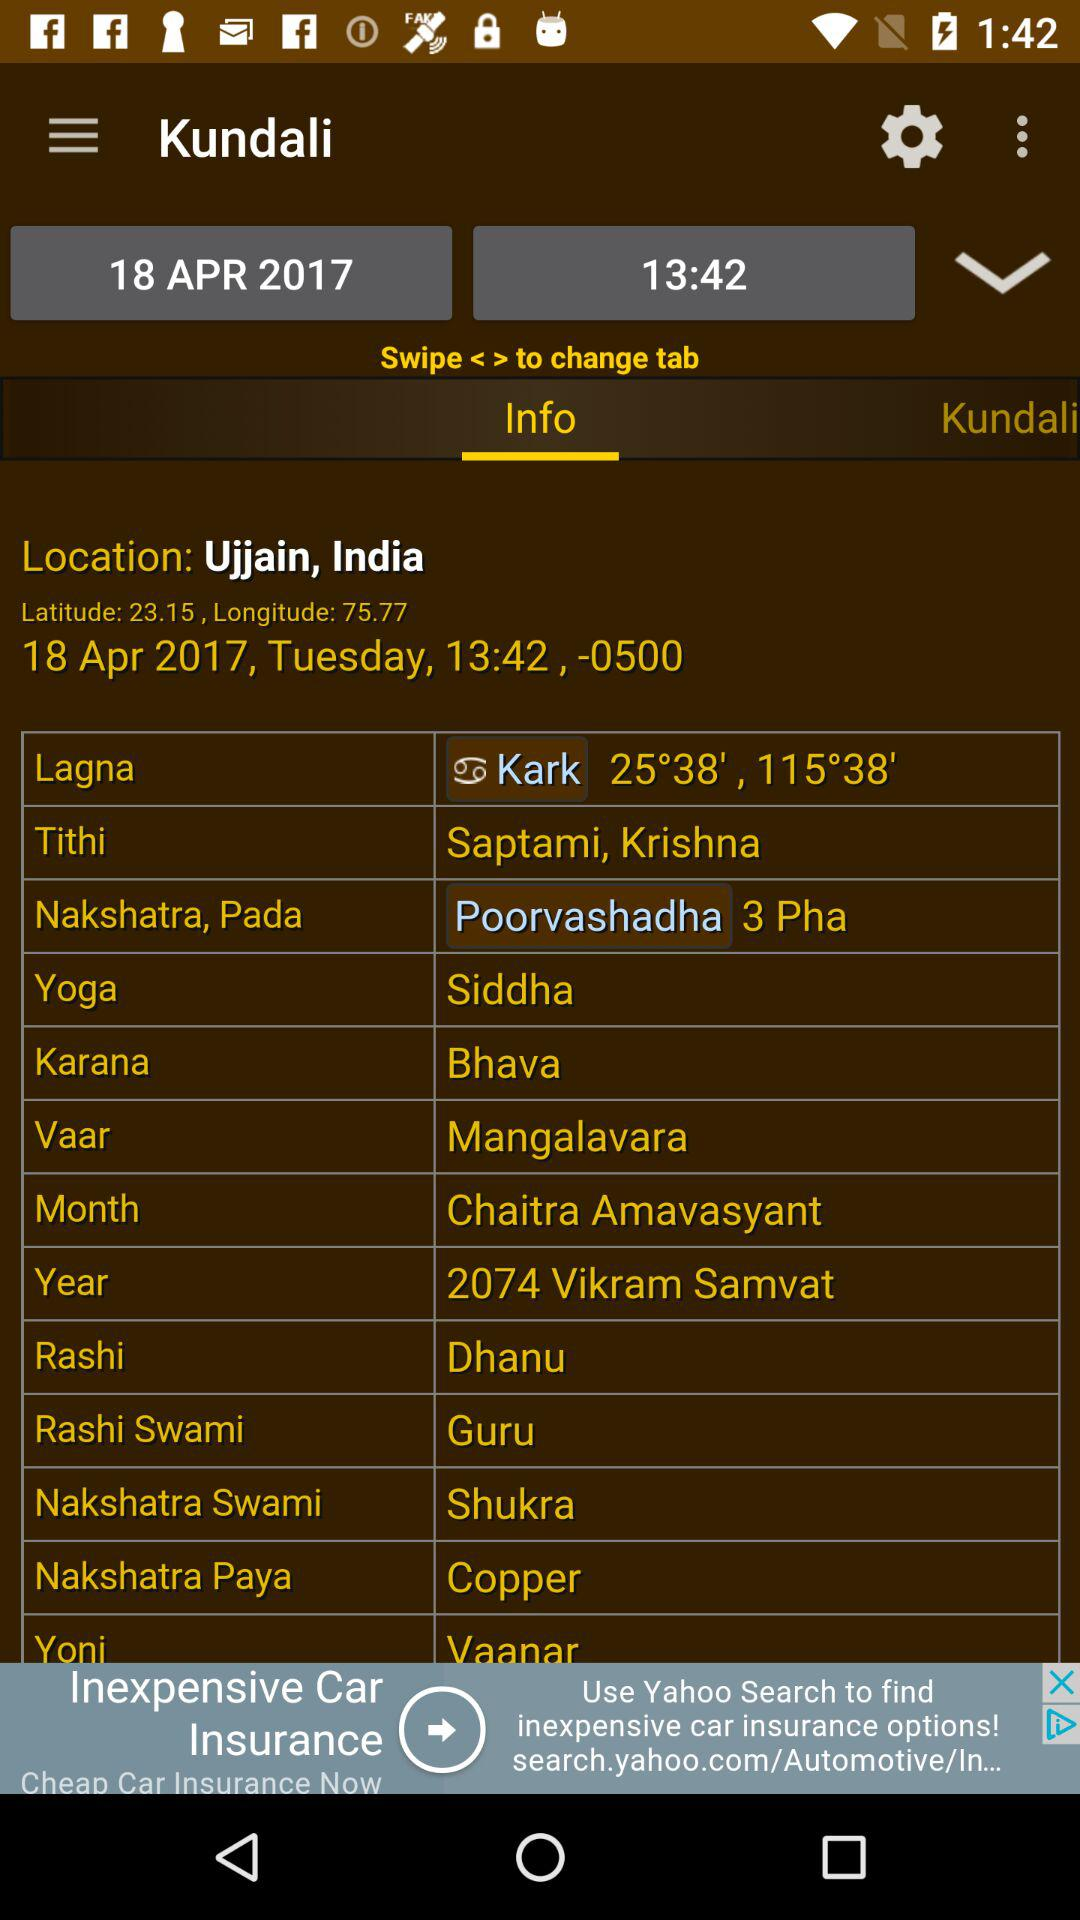What is the month? The month is April. 